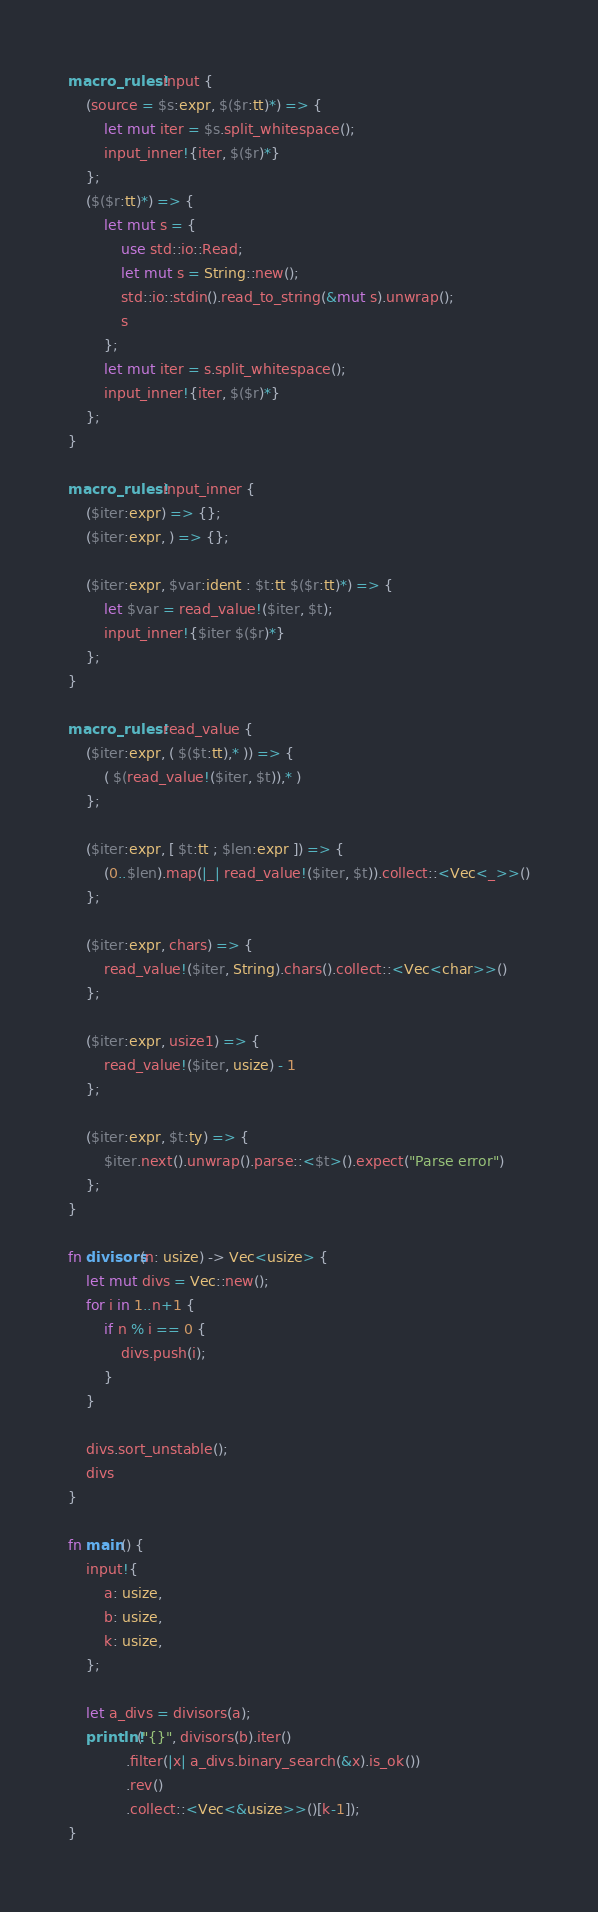<code> <loc_0><loc_0><loc_500><loc_500><_Rust_>macro_rules! input {
    (source = $s:expr, $($r:tt)*) => {
        let mut iter = $s.split_whitespace();
        input_inner!{iter, $($r)*}
    };
    ($($r:tt)*) => {
        let mut s = {
            use std::io::Read;
            let mut s = String::new();
            std::io::stdin().read_to_string(&mut s).unwrap();
            s
        };
        let mut iter = s.split_whitespace();
        input_inner!{iter, $($r)*}
    };
}

macro_rules! input_inner {
    ($iter:expr) => {};
    ($iter:expr, ) => {};

    ($iter:expr, $var:ident : $t:tt $($r:tt)*) => {
        let $var = read_value!($iter, $t);
        input_inner!{$iter $($r)*}
    };
}

macro_rules! read_value {
    ($iter:expr, ( $($t:tt),* )) => {
        ( $(read_value!($iter, $t)),* )
    };

    ($iter:expr, [ $t:tt ; $len:expr ]) => {
        (0..$len).map(|_| read_value!($iter, $t)).collect::<Vec<_>>()
    };

    ($iter:expr, chars) => {
        read_value!($iter, String).chars().collect::<Vec<char>>()
    };

    ($iter:expr, usize1) => {
        read_value!($iter, usize) - 1
    };

    ($iter:expr, $t:ty) => {
        $iter.next().unwrap().parse::<$t>().expect("Parse error")
    };
}

fn divisors(n: usize) -> Vec<usize> {
    let mut divs = Vec::new();
    for i in 1..n+1 {
        if n % i == 0 {
            divs.push(i);
        }
    }

    divs.sort_unstable();
    divs
}

fn main() {
    input!{
        a: usize,
        b: usize,
        k: usize,
    };

    let a_divs = divisors(a);
    println!("{}", divisors(b).iter()
             .filter(|x| a_divs.binary_search(&x).is_ok())
             .rev()
             .collect::<Vec<&usize>>()[k-1]);
}
</code> 